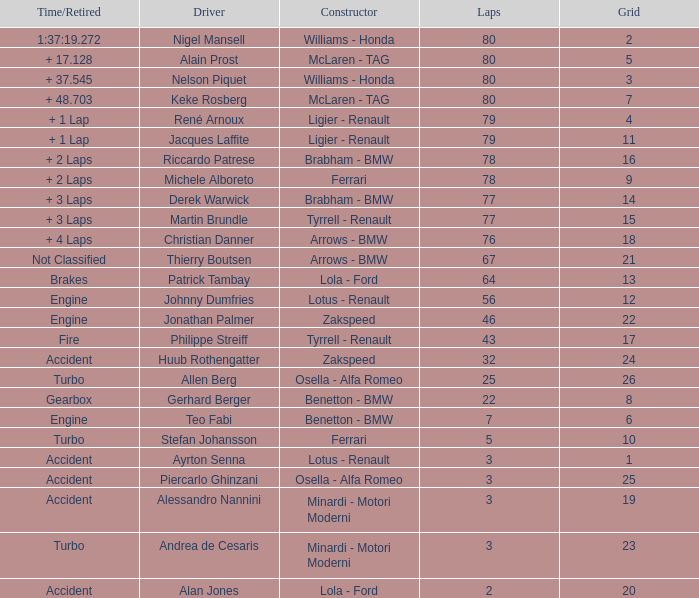What is the time/retired for thierry boutsen? Not Classified. 